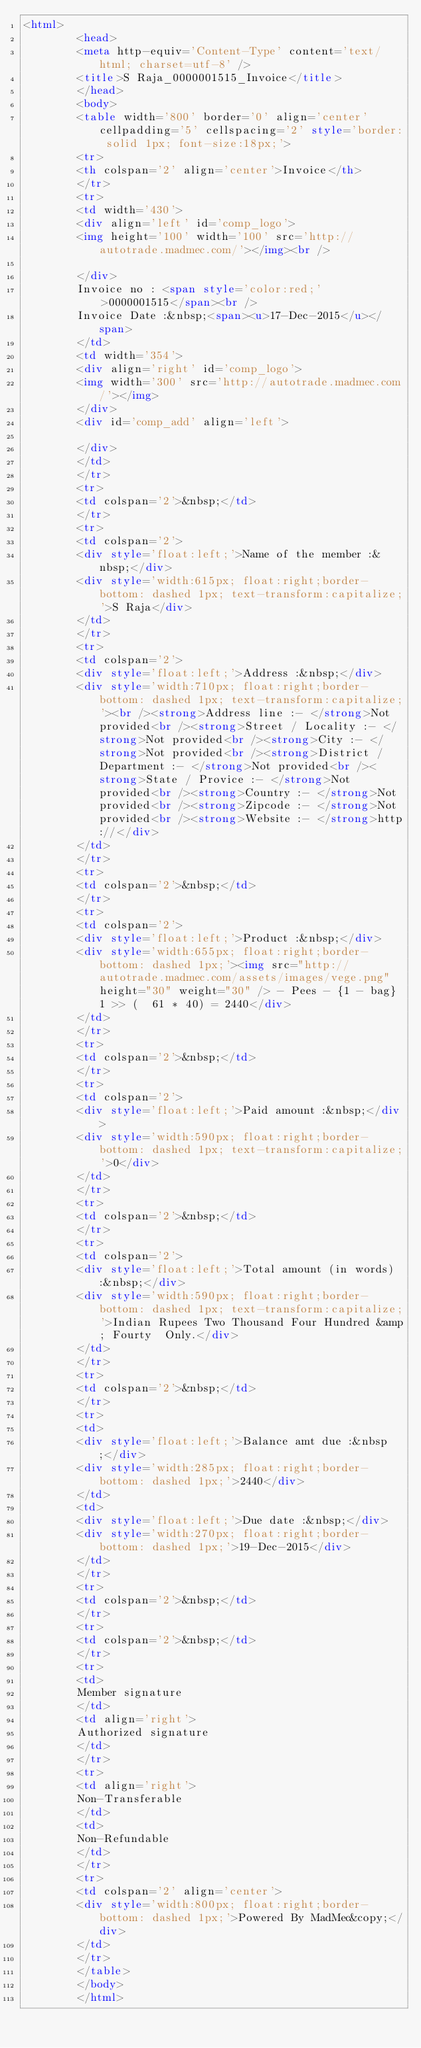Convert code to text. <code><loc_0><loc_0><loc_500><loc_500><_HTML_><html>
		<head>
		<meta http-equiv='Content-Type' content='text/html; charset=utf-8' />
		<title>S Raja_0000001515_Invoice</title>
		</head>
		<body>
		<table width='800' border='0' align='center' cellpadding='5' cellspacing='2' style='border: solid 1px; font-size:18px;'>
		<tr>
		<th colspan='2' align='center'>Invoice</th>
		</tr>
		<tr>
		<td width='430'>
		<div align='left' id='comp_logo'>
		<img height='100' width='100' src='http://autotrade.madmec.com/'></img><br />

		</div>
		Invoice no : <span style='color:red;'>0000001515</span><br />
		Invoice Date :&nbsp;<span><u>17-Dec-2015</u></span>
		</td>
		<td width='354'>
		<div align='right' id='comp_logo'>
		<img width='300' src='http://autotrade.madmec.com/'></img>
		</div>
		<div id='comp_add' align='left'>
		
		</div>
		</td>
		</tr>
		<tr>
		<td colspan='2'>&nbsp;</td>
		</tr>
		<tr>
		<td colspan='2'>
		<div style='float:left;'>Name of the member :&nbsp;</div>
		<div style='width:615px; float:right;border-bottom: dashed 1px; text-transform:capitalize;'>S Raja</div>
		</td>
		</tr>
		<tr>
		<td colspan='2'>
		<div style='float:left;'>Address :&nbsp;</div>
		<div style='width:710px; float:right;border-bottom: dashed 1px; text-transform:capitalize;'><br /><strong>Address line :- </strong>Not provided<br /><strong>Street / Locality :- </strong>Not provided<br /><strong>City :- </strong>Not provided<br /><strong>District / Department :- </strong>Not provided<br /><strong>State / Provice :- </strong>Not provided<br /><strong>Country :- </strong>Not provided<br /><strong>Zipcode :- </strong>Not provided<br /><strong>Website :- </strong>http://</div>
		</td>
		</tr>
		<tr>
		<td colspan='2'>&nbsp;</td>
		</tr>
		<tr>
		<td colspan='2'>
		<div style='float:left;'>Product :&nbsp;</div>
		<div style='width:655px; float:right;border-bottom: dashed 1px;'><img src="http://autotrade.madmec.com/assets/images/vege.png" height="30" weight="30" /> - Pees - {1 - bag} 1 >> (  61 * 40) = 2440</div>
		</td>
		</tr>
		<tr>
		<td colspan='2'>&nbsp;</td>
		</tr>
		<tr>
		<td colspan='2'>
		<div style='float:left;'>Paid amount :&nbsp;</div>
		<div style='width:590px; float:right;border-bottom: dashed 1px; text-transform:capitalize;'>0</div>
		</td>
		</tr>
		<tr>
		<td colspan='2'>&nbsp;</td>
		</tr>
		<tr>
		<td colspan='2'>
		<div style='float:left;'>Total amount (in words) :&nbsp;</div>
		<div style='width:590px; float:right;border-bottom: dashed 1px; text-transform:capitalize;'>Indian Rupees Two Thousand Four Hundred &amp; Fourty  Only.</div>
		</td>
		</tr>
		<tr>
		<td colspan='2'>&nbsp;</td>
		</tr>
		<tr>
		<td>
		<div style='float:left;'>Balance amt due :&nbsp;</div>
		<div style='width:285px; float:right;border-bottom: dashed 1px;'>2440</div>
		</td>
		<td>
		<div style='float:left;'>Due date :&nbsp;</div>
		<div style='width:270px; float:right;border-bottom: dashed 1px;'>19-Dec-2015</div>
		</td>
		</tr>
		<tr>
		<td colspan='2'>&nbsp;</td>
		</tr>
		<tr>
		<td colspan='2'>&nbsp;</td>
		</tr>
		<tr>
		<td>
		Member signature
		</td>
		<td align='right'>
		Authorized signature
		</td>
		</tr>
		<tr>
		<td align='right'>
		Non-Transferable
		</td>
		<td>
		Non-Refundable
		</td>
		</tr>
		<tr>
		<td colspan='2' align='center'>
		<div style='width:800px; float:right;border-bottom: dashed 1px;'>Powered By MadMec&copy;</div>
		</td>
		</tr>
		</table>
		</body>
		</html></code> 